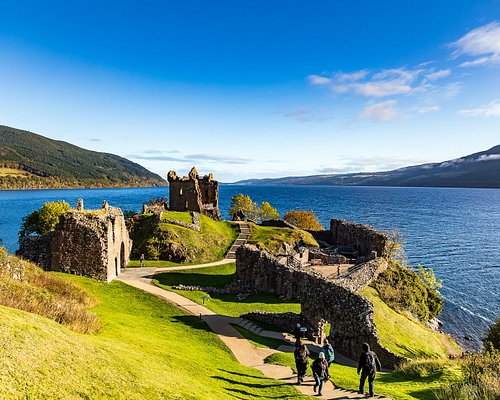Can you explain the significance of Loch Ness in relation to Urquhart Castle? Loch Ness plays a pivotal role in defining the historical and cultural context of Urquhart Castle. The loch not only provided a natural defense barrier but also was a major route for trade and transportation in medieval Scotland. This, coupled with the loch's mythical associations with the Loch Ness Monster, adds a layer of mystique and draws substantial tourist attention to the castle and the surrounding area. Has the Loch Ness Monster ever been sighted near the castle? Yes, Urquhart Castle is one of the prime locations for alleged sightings of the Loch Ness Monster, affectionately known as Nessie. The castle's strategic viewpoints overlooking the loch make it a popular spot for those hoping to catch a glimpse of the mythical creature, contributing to its folklore and attraction. 